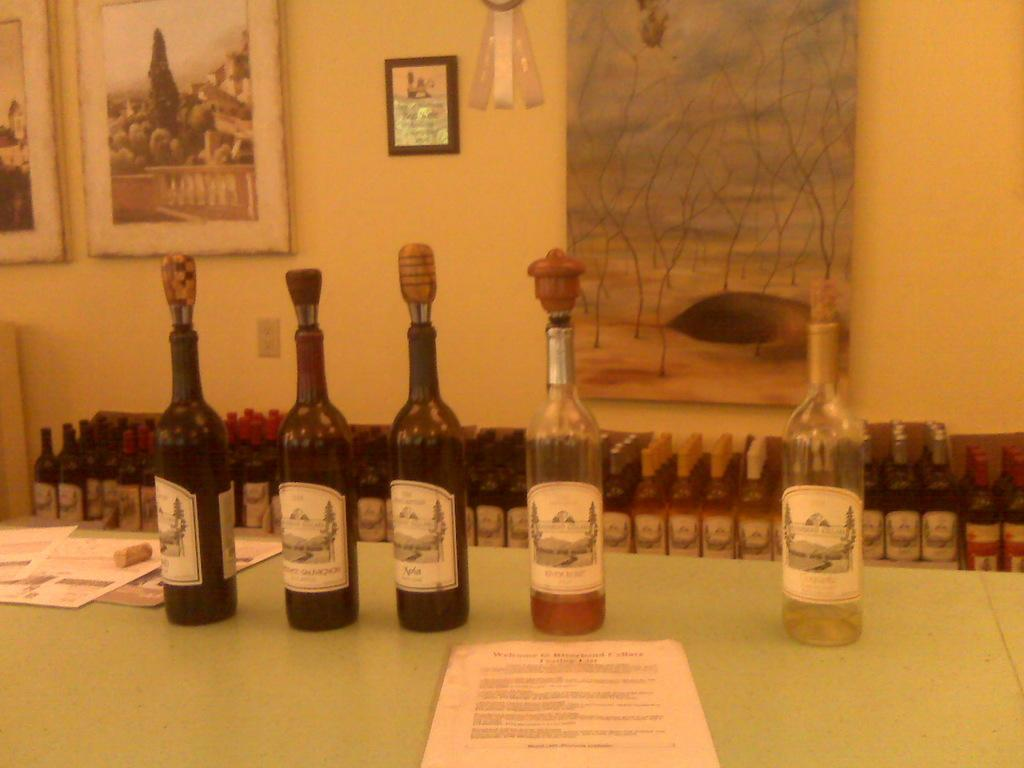<image>
Write a terse but informative summary of the picture. 5 wine bottles on a table have fancy corks with a Merlot in the center. 